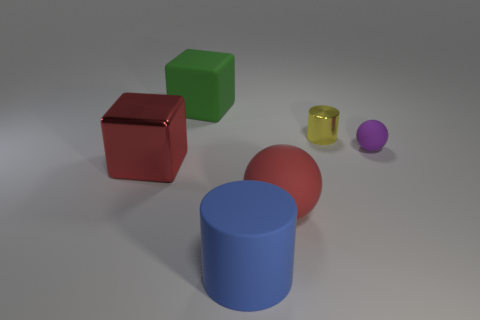Add 3 large yellow metallic cylinders. How many objects exist? 9 Subtract all blocks. How many objects are left? 4 Subtract all yellow cubes. Subtract all big rubber cylinders. How many objects are left? 5 Add 4 shiny objects. How many shiny objects are left? 6 Add 2 balls. How many balls exist? 4 Subtract 0 green cylinders. How many objects are left? 6 